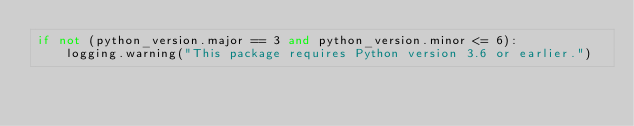Convert code to text. <code><loc_0><loc_0><loc_500><loc_500><_Python_>if not (python_version.major == 3 and python_version.minor <= 6):
    logging.warning("This package requires Python version 3.6 or earlier.")
</code> 